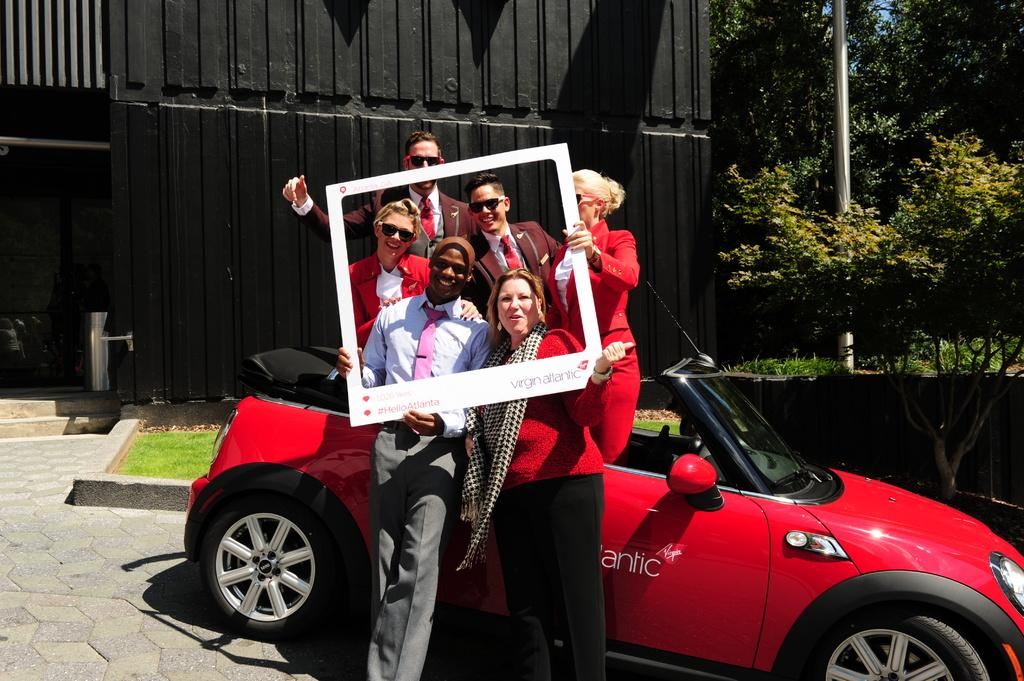How many people are present in the image? There are six people standing in the image. What can be seen besides the people in the image? There is a car in the image. What type of natural scenery is visible in the image? There are trees visible at the back side of the image. What type of badge can be seen on the trees in the image? There are no badges present on the trees in the image. Can you describe the fog in the image? There is no fog present in the image. 